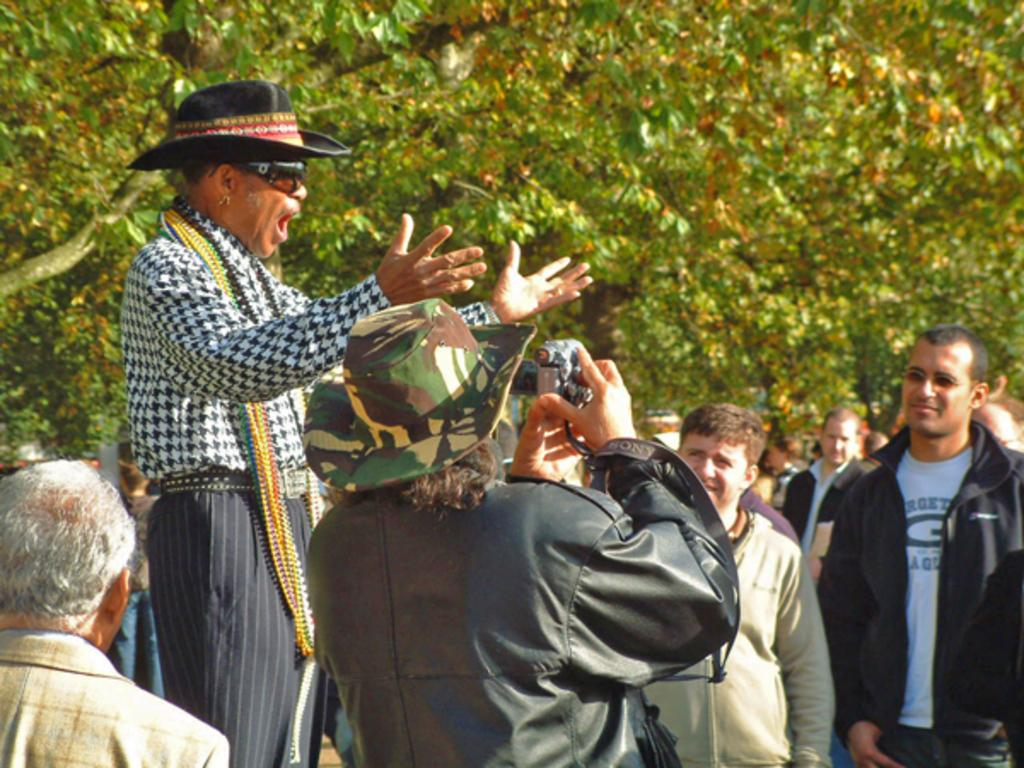How many people are in the image? There are people in the image, but the exact number is not specified. What is the person in the center doing? The person standing in the center is holding a camera. What can be seen in the background of the image? There are trees in the background of the image. What type of hospital can be seen in the image? There is no hospital present in the image. Is the ground in the image sloped or flat? The facts provided do not mention the slope or flatness of the ground in the image. Can you see anyone taking a bath in the image? There is no indication of a bath or anyone taking a bath in the image. 